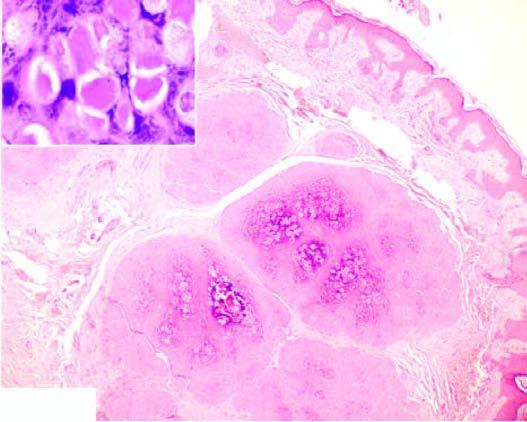does inset show close-up view of molluscum bodies?
Answer the question using a single word or phrase. Yes 